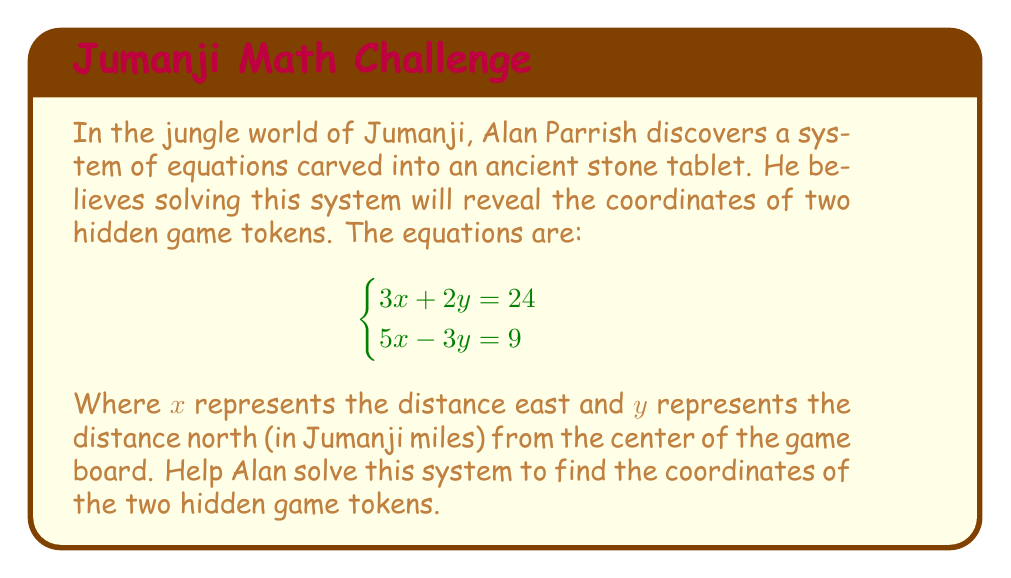Show me your answer to this math problem. Let's solve this system of equations using the elimination method:

1) First, we'll multiply the first equation by 3 and the second equation by 2:

   $$\begin{cases}
   9x + 6y = 72 \\
   10x - 6y = 18
   \end{cases}$$

2) Now, we can add these equations to eliminate $y$:

   $(9x + 6y) + (10x - 6y) = 72 + 18$
   $19x = 90$

3) Solve for $x$:

   $x = \frac{90}{19} \approx 4.74$

4) Substitute this value of $x$ back into one of the original equations. Let's use the first one:

   $3(4.74) + 2y = 24$
   $14.22 + 2y = 24$
   $2y = 24 - 14.22 = 9.78$
   $y = 4.89$

5) We can verify this solution satisfies both equations:

   $3(4.74) + 2(4.89) \approx 24$
   $5(4.74) - 3(4.89) \approx 9$

Therefore, the coordinates of the hidden game tokens are approximately (4.74, 4.89) Jumanji miles from the center of the game board.
Answer: The coordinates of the hidden game tokens are approximately (4.74, 4.89) Jumanji miles east and north from the center of the game board. 